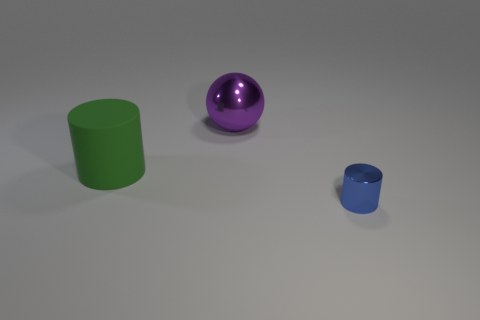What shape is the other metallic object that is the same size as the green object?
Ensure brevity in your answer.  Sphere. What is the color of the metal object that is to the left of the tiny cylinder?
Make the answer very short. Purple. What number of other things are made of the same material as the purple thing?
Provide a short and direct response. 1. Is the number of rubber cylinders that are to the right of the metal ball greater than the number of big objects on the right side of the large matte cylinder?
Make the answer very short. No. What number of big rubber things are right of the purple metal sphere?
Your response must be concise. 0. Is the material of the purple object the same as the cylinder behind the small blue shiny thing?
Your answer should be compact. No. Is there any other thing that has the same shape as the big rubber thing?
Ensure brevity in your answer.  Yes. Is the tiny blue cylinder made of the same material as the green cylinder?
Make the answer very short. No. Are there any tiny cylinders left of the large object that is behind the green thing?
Make the answer very short. No. What number of things are both on the right side of the matte cylinder and in front of the large purple metallic sphere?
Keep it short and to the point. 1. 